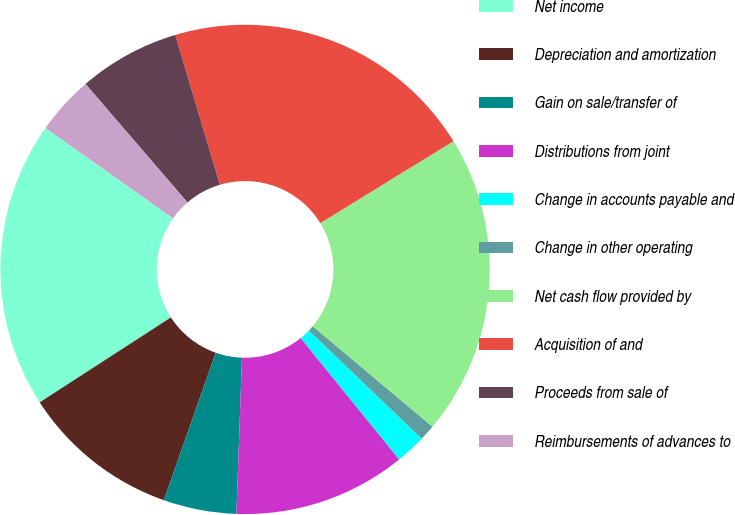<chart> <loc_0><loc_0><loc_500><loc_500><pie_chart><fcel>Net income<fcel>Depreciation and amortization<fcel>Gain on sale/transfer of<fcel>Distributions from joint<fcel>Change in accounts payable and<fcel>Change in other operating<fcel>Net cash flow provided by<fcel>Acquisition of and<fcel>Proceeds from sale of<fcel>Reimbursements of advances to<nl><fcel>18.95%<fcel>10.47%<fcel>4.82%<fcel>11.41%<fcel>1.99%<fcel>1.05%<fcel>19.89%<fcel>20.83%<fcel>6.7%<fcel>3.88%<nl></chart> 